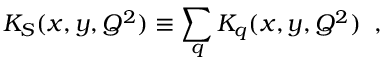<formula> <loc_0><loc_0><loc_500><loc_500>K _ { S } ( x , y , Q ^ { 2 } ) \equiv \sum _ { q } K _ { q } ( x , y , Q ^ { 2 } ) \, ,</formula> 